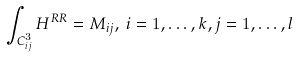<formula> <loc_0><loc_0><loc_500><loc_500>\int _ { C _ { i j } ^ { 3 } } H ^ { R R } = M _ { i j } , \, i = 1 , \dots , k , j = 1 , \dots , l</formula> 